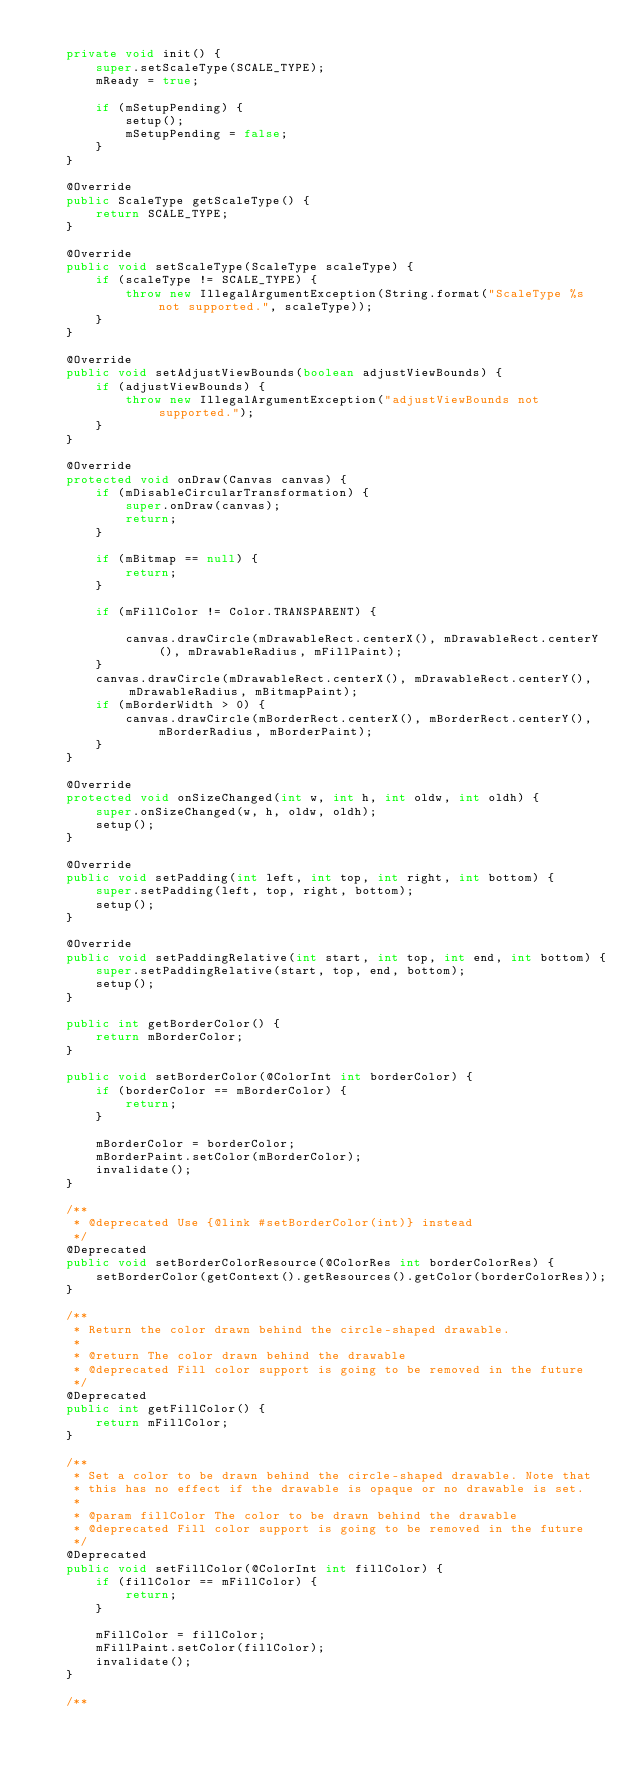Convert code to text. <code><loc_0><loc_0><loc_500><loc_500><_Java_>
    private void init() {
        super.setScaleType(SCALE_TYPE);
        mReady = true;

        if (mSetupPending) {
            setup();
            mSetupPending = false;
        }
    }

    @Override
    public ScaleType getScaleType() {
        return SCALE_TYPE;
    }

    @Override
    public void setScaleType(ScaleType scaleType) {
        if (scaleType != SCALE_TYPE) {
            throw new IllegalArgumentException(String.format("ScaleType %s not supported.", scaleType));
        }
    }

    @Override
    public void setAdjustViewBounds(boolean adjustViewBounds) {
        if (adjustViewBounds) {
            throw new IllegalArgumentException("adjustViewBounds not supported.");
        }
    }

    @Override
    protected void onDraw(Canvas canvas) {
        if (mDisableCircularTransformation) {
            super.onDraw(canvas);
            return;
        }

        if (mBitmap == null) {
            return;
        }

        if (mFillColor != Color.TRANSPARENT) {

            canvas.drawCircle(mDrawableRect.centerX(), mDrawableRect.centerY(), mDrawableRadius, mFillPaint);
        }
        canvas.drawCircle(mDrawableRect.centerX(), mDrawableRect.centerY(), mDrawableRadius, mBitmapPaint);
        if (mBorderWidth > 0) {
            canvas.drawCircle(mBorderRect.centerX(), mBorderRect.centerY(), mBorderRadius, mBorderPaint);
        }
    }

    @Override
    protected void onSizeChanged(int w, int h, int oldw, int oldh) {
        super.onSizeChanged(w, h, oldw, oldh);
        setup();
    }

    @Override
    public void setPadding(int left, int top, int right, int bottom) {
        super.setPadding(left, top, right, bottom);
        setup();
    }

    @Override
    public void setPaddingRelative(int start, int top, int end, int bottom) {
        super.setPaddingRelative(start, top, end, bottom);
        setup();
    }

    public int getBorderColor() {
        return mBorderColor;
    }

    public void setBorderColor(@ColorInt int borderColor) {
        if (borderColor == mBorderColor) {
            return;
        }

        mBorderColor = borderColor;
        mBorderPaint.setColor(mBorderColor);
        invalidate();
    }

    /**
     * @deprecated Use {@link #setBorderColor(int)} instead
     */
    @Deprecated
    public void setBorderColorResource(@ColorRes int borderColorRes) {
        setBorderColor(getContext().getResources().getColor(borderColorRes));
    }

    /**
     * Return the color drawn behind the circle-shaped drawable.
     *
     * @return The color drawn behind the drawable
     * @deprecated Fill color support is going to be removed in the future
     */
    @Deprecated
    public int getFillColor() {
        return mFillColor;
    }

    /**
     * Set a color to be drawn behind the circle-shaped drawable. Note that
     * this has no effect if the drawable is opaque or no drawable is set.
     *
     * @param fillColor The color to be drawn behind the drawable
     * @deprecated Fill color support is going to be removed in the future
     */
    @Deprecated
    public void setFillColor(@ColorInt int fillColor) {
        if (fillColor == mFillColor) {
            return;
        }

        mFillColor = fillColor;
        mFillPaint.setColor(fillColor);
        invalidate();
    }

    /**</code> 